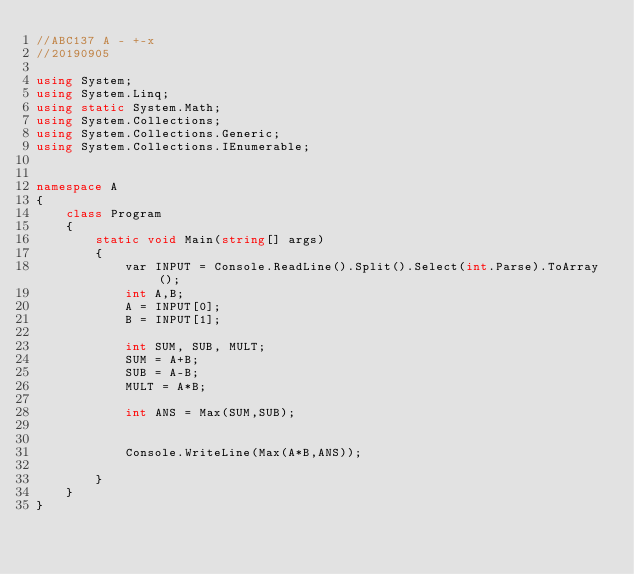<code> <loc_0><loc_0><loc_500><loc_500><_C#_>//ABC137 A - +-x
//20190905

using System;
using System.Linq;
using static System.Math;
using System.Collections;
using System.Collections.Generic;
using System.Collections.IEnumerable;


namespace A
{
    class Program
    {
        static void Main(string[] args)
        {
            var INPUT = Console.ReadLine().Split().Select(int.Parse).ToArray();
            int A,B;
            A = INPUT[0];
            B = INPUT[1];

            int SUM, SUB, MULT;
            SUM = A+B;
            SUB = A-B;
            MULT = A*B;

            int ANS = Max(SUM,SUB);
            

            Console.WriteLine(Max(A*B,ANS));

        }
    }
}
</code> 